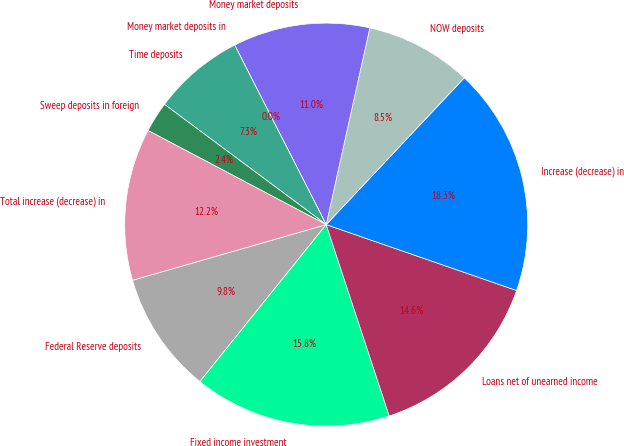Convert chart to OTSL. <chart><loc_0><loc_0><loc_500><loc_500><pie_chart><fcel>Federal Reserve deposits<fcel>Fixed income investment<fcel>Loans net of unearned income<fcel>Increase (decrease) in<fcel>NOW deposits<fcel>Money market deposits<fcel>Money market deposits in<fcel>Time deposits<fcel>Sweep deposits in foreign<fcel>Total increase (decrease) in<nl><fcel>9.76%<fcel>15.85%<fcel>14.63%<fcel>18.29%<fcel>8.54%<fcel>10.98%<fcel>0.0%<fcel>7.32%<fcel>2.44%<fcel>12.19%<nl></chart> 